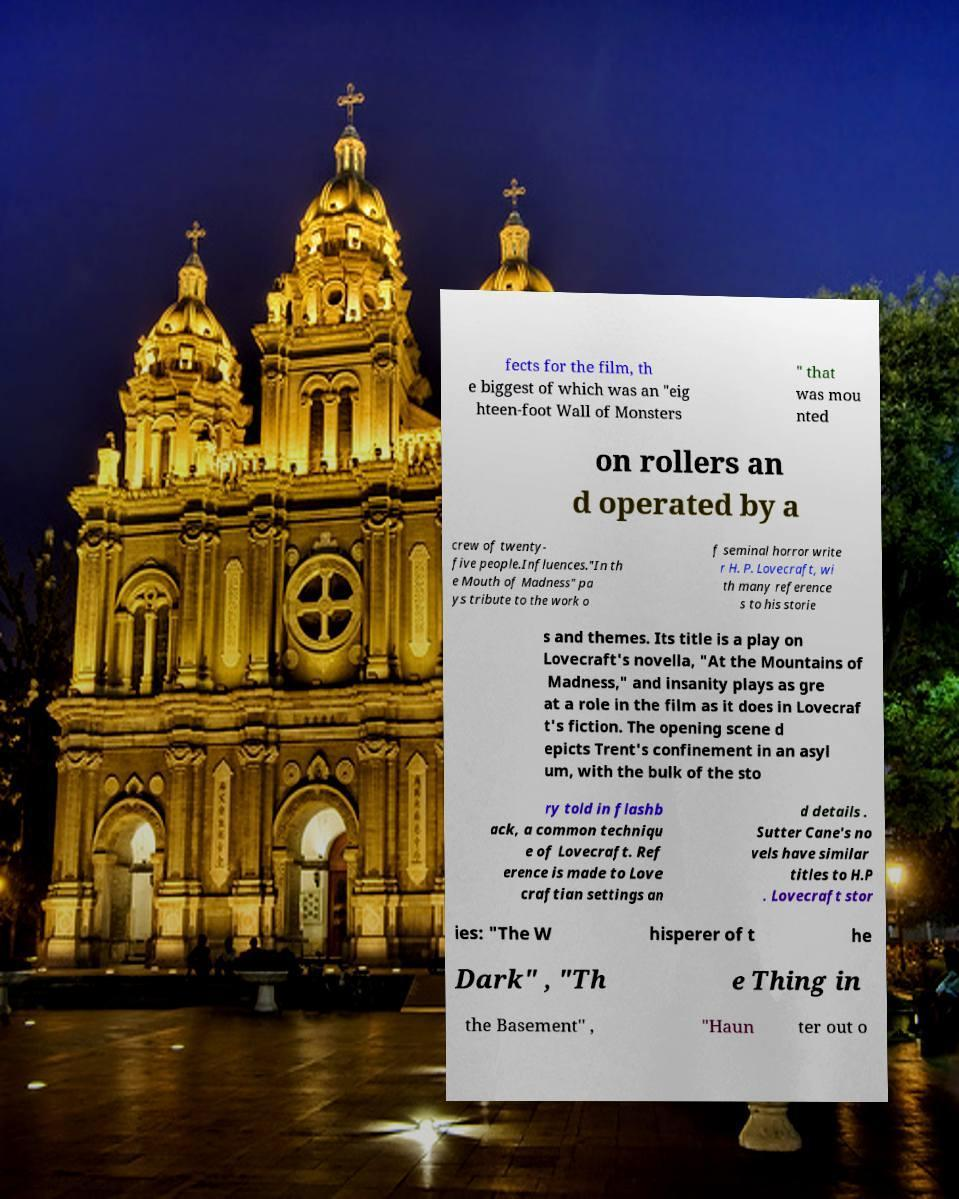Please identify and transcribe the text found in this image. fects for the film, th e biggest of which was an "eig hteen-foot Wall of Monsters " that was mou nted on rollers an d operated by a crew of twenty- five people.Influences."In th e Mouth of Madness" pa ys tribute to the work o f seminal horror write r H. P. Lovecraft, wi th many reference s to his storie s and themes. Its title is a play on Lovecraft's novella, "At the Mountains of Madness," and insanity plays as gre at a role in the film as it does in Lovecraf t's fiction. The opening scene d epicts Trent's confinement in an asyl um, with the bulk of the sto ry told in flashb ack, a common techniqu e of Lovecraft. Ref erence is made to Love craftian settings an d details . Sutter Cane's no vels have similar titles to H.P . Lovecraft stor ies: "The W hisperer of t he Dark" , "Th e Thing in the Basement" , "Haun ter out o 